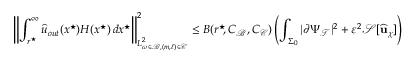<formula> <loc_0><loc_0><loc_500><loc_500>\left \| \int _ { r ^ { ^ { * } } \, } ^ { \infty } { \widehat { u } } _ { o u t } ( x ^ { ^ { * } } ) H ( x ^ { ^ { * } } ) \, d x ^ { ^ { * } } \right \| _ { L _ { \omega \in \mathcal { B } , ( m , \ell ) \in \mathcal { C } } ^ { 2 } } ^ { 2 } \leq B ( r ^ { ^ { * } } \, , C _ { \mathcal { B } } , C _ { \mathcal { C } } ) \left ( \int _ { \Sigma _ { 0 } } | \partial \Psi _ { \mathcal { T } } | ^ { 2 } + \varepsilon ^ { 2 } \mathcal { S } [ \widehat { u } _ { \chi } ] \right )</formula> 